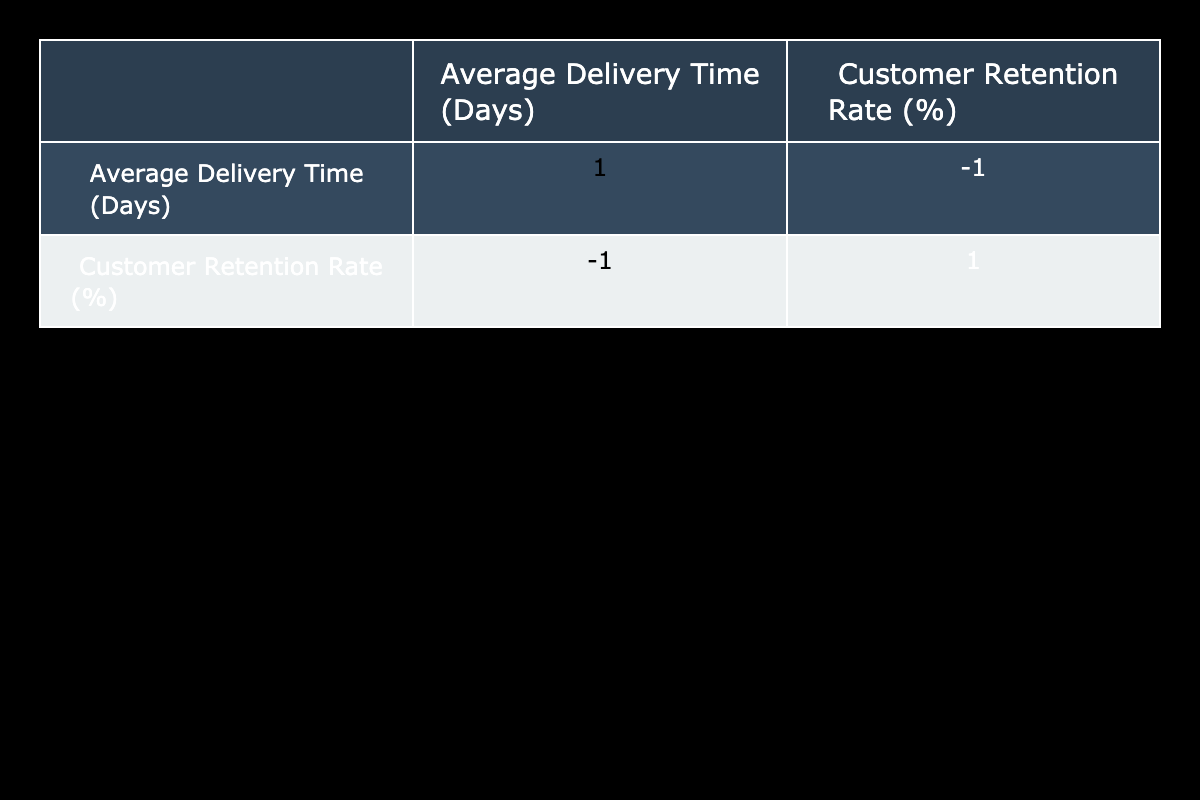What is the correlation coefficient between Average Delivery Time and Customer Retention Rate? By looking at the correlation table, I can determine the correlation coefficient for Average Delivery Time and Customer Retention Rate is -0.99, which indicates a strong negative correlation.
Answer: -0.99 What is the Customer Retention Rate when Average Delivery Time is 5 days? According to the table, when the Average Delivery Time is 5 days, the Customer Retention Rate is 65%.
Answer: 65% Is there a Customer Retention Rate of 80% or higher for any Average Delivery Time? The table shows that the Customer Retention Rates for Average Delivery Times of 1 day and 2 days are 85% and 80%, respectively. Therefore, yes, there are retention rates of 80% or higher.
Answer: Yes What is the difference in Customer Retention Rate between 2 days and 7 days of Average Delivery Time? For 2 days of Average Delivery Time, the retention rate is 80%, and for 7 days, it is 55%. The difference is calculated by subtracting 55 from 80, resulting in 25.
Answer: 25 What is the Average Customer Retention Rate for Average Delivery Times less than or equal to 6 days? The Customer Retention Rates for Average Delivery Times of 1 to 6 days are 85%, 80%, 75%, 70%, 65%, and 60%. To find the average, I add these values (85 + 80 + 75 + 70 + 65 + 60) = 435 and divide by 6 (the number of days) resulting in an average of 72.5.
Answer: 72.5 